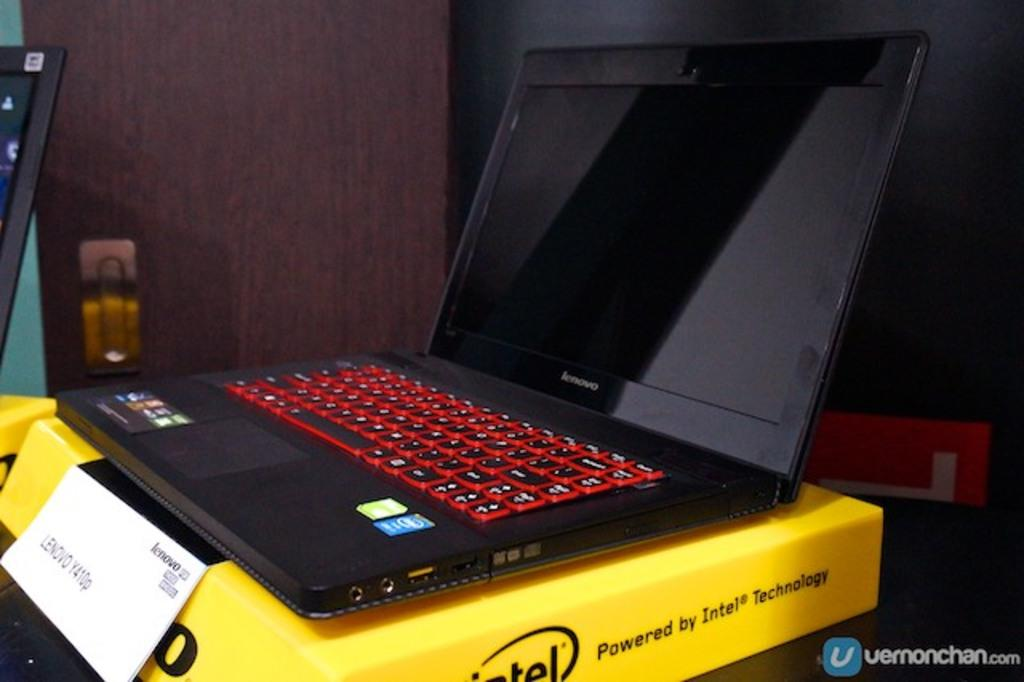Provide a one-sentence caption for the provided image. a levovo y410p intel laptop with gaming keyboard. 